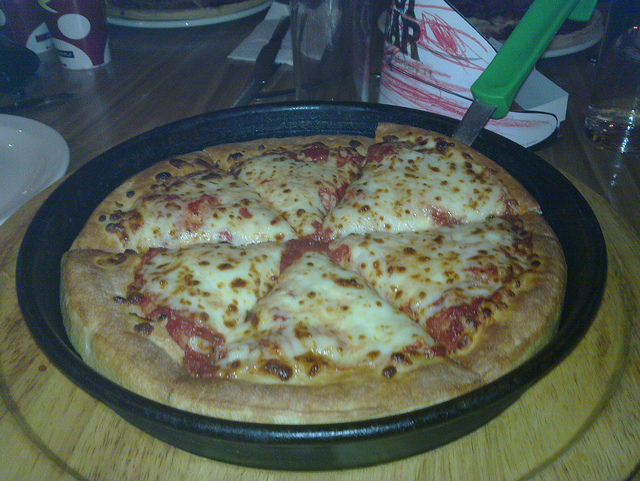<image>Which fruit is in the 3rd row of this platter? There is no fruit in the 3rd row of this platter. Which fruit is in the 3rd row of this platter? I don't know which fruit is in the 3rd row of this platter. It can be cheese, tomato, or no fruit at all. 